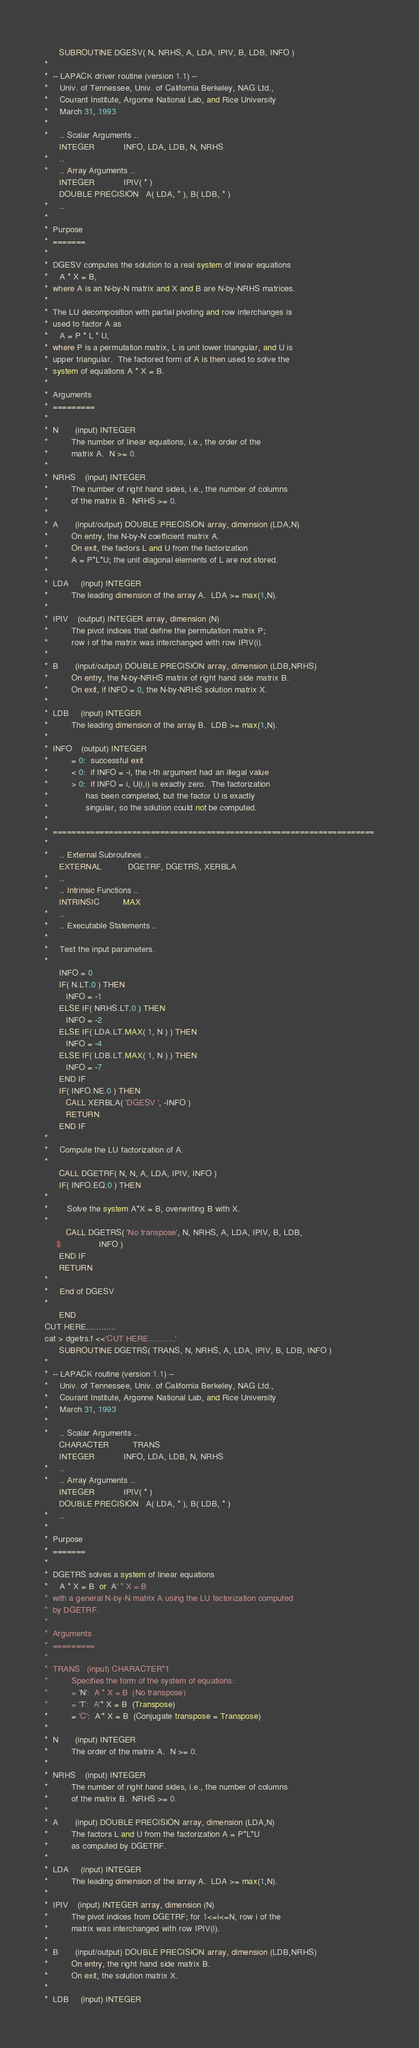<code> <loc_0><loc_0><loc_500><loc_500><_FORTRAN_>
      SUBROUTINE DGESV( N, NRHS, A, LDA, IPIV, B, LDB, INFO )
*
*  -- LAPACK driver routine (version 1.1) --
*     Univ. of Tennessee, Univ. of California Berkeley, NAG Ltd.,
*     Courant Institute, Argonne National Lab, and Rice University
*     March 31, 1993
*
*     .. Scalar Arguments ..
      INTEGER            INFO, LDA, LDB, N, NRHS
*     ..
*     .. Array Arguments ..
      INTEGER            IPIV( * )
      DOUBLE PRECISION   A( LDA, * ), B( LDB, * )
*     ..
*
*  Purpose
*  =======
*
*  DGESV computes the solution to a real system of linear equations
*     A * X = B,
*  where A is an N-by-N matrix and X and B are N-by-NRHS matrices.
*
*  The LU decomposition with partial pivoting and row interchanges is
*  used to factor A as
*     A = P * L * U,
*  where P is a permutation matrix, L is unit lower triangular, and U is
*  upper triangular.  The factored form of A is then used to solve the
*  system of equations A * X = B.
*
*  Arguments
*  =========
*
*  N       (input) INTEGER
*          The number of linear equations, i.e., the order of the
*          matrix A.  N >= 0.
*
*  NRHS    (input) INTEGER
*          The number of right hand sides, i.e., the number of columns
*          of the matrix B.  NRHS >= 0.
*
*  A       (input/output) DOUBLE PRECISION array, dimension (LDA,N)
*          On entry, the N-by-N coefficient matrix A.
*          On exit, the factors L and U from the factorization
*          A = P*L*U; the unit diagonal elements of L are not stored.
*
*  LDA     (input) INTEGER
*          The leading dimension of the array A.  LDA >= max(1,N).
*
*  IPIV    (output) INTEGER array, dimension (N)
*          The pivot indices that define the permutation matrix P;
*          row i of the matrix was interchanged with row IPIV(i).
*
*  B       (input/output) DOUBLE PRECISION array, dimension (LDB,NRHS)
*          On entry, the N-by-NRHS matrix of right hand side matrix B.
*          On exit, if INFO = 0, the N-by-NRHS solution matrix X.
*
*  LDB     (input) INTEGER
*          The leading dimension of the array B.  LDB >= max(1,N).
*
*  INFO    (output) INTEGER
*          = 0:  successful exit
*          < 0:  if INFO = -i, the i-th argument had an illegal value
*          > 0:  if INFO = i, U(i,i) is exactly zero.  The factorization
*                has been completed, but the factor U is exactly
*                singular, so the solution could not be computed.
*
*  =====================================================================
*
*     .. External Subroutines ..
      EXTERNAL           DGETRF, DGETRS, XERBLA
*     ..
*     .. Intrinsic Functions ..
      INTRINSIC          MAX
*     ..
*     .. Executable Statements ..
*
*     Test the input parameters.
*
      INFO = 0
      IF( N.LT.0 ) THEN
         INFO = -1
      ELSE IF( NRHS.LT.0 ) THEN
         INFO = -2
      ELSE IF( LDA.LT.MAX( 1, N ) ) THEN
         INFO = -4
      ELSE IF( LDB.LT.MAX( 1, N ) ) THEN
         INFO = -7
      END IF
      IF( INFO.NE.0 ) THEN
         CALL XERBLA( 'DGESV ', -INFO )
         RETURN
      END IF
*
*     Compute the LU factorization of A.
*
      CALL DGETRF( N, N, A, LDA, IPIV, INFO )
      IF( INFO.EQ.0 ) THEN
*
*        Solve the system A*X = B, overwriting B with X.
*
         CALL DGETRS( 'No transpose', N, NRHS, A, LDA, IPIV, B, LDB,
     $                INFO )
      END IF
      RETURN
*
*     End of DGESV
*
      END
CUT HERE............
cat > dgetrs.f <<'CUT HERE............'
      SUBROUTINE DGETRS( TRANS, N, NRHS, A, LDA, IPIV, B, LDB, INFO )
*
*  -- LAPACK routine (version 1.1) --
*     Univ. of Tennessee, Univ. of California Berkeley, NAG Ltd.,
*     Courant Institute, Argonne National Lab, and Rice University
*     March 31, 1993
*
*     .. Scalar Arguments ..
      CHARACTER          TRANS
      INTEGER            INFO, LDA, LDB, N, NRHS
*     ..
*     .. Array Arguments ..
      INTEGER            IPIV( * )
      DOUBLE PRECISION   A( LDA, * ), B( LDB, * )
*     ..
*
*  Purpose
*  =======
*
*  DGETRS solves a system of linear equations
*     A * X = B  or  A' * X = B
*  with a general N-by-N matrix A using the LU factorization computed
*  by DGETRF.
*
*  Arguments
*  =========
*
*  TRANS   (input) CHARACTER*1
*          Specifies the form of the system of equations:
*          = 'N':  A * X = B  (No transpose)
*          = 'T':  A'* X = B  (Transpose)
*          = 'C':  A'* X = B  (Conjugate transpose = Transpose)
*
*  N       (input) INTEGER
*          The order of the matrix A.  N >= 0.
*
*  NRHS    (input) INTEGER
*          The number of right hand sides, i.e., the number of columns
*          of the matrix B.  NRHS >= 0.
*
*  A       (input) DOUBLE PRECISION array, dimension (LDA,N)
*          The factors L and U from the factorization A = P*L*U
*          as computed by DGETRF.
*
*  LDA     (input) INTEGER
*          The leading dimension of the array A.  LDA >= max(1,N).
*
*  IPIV    (input) INTEGER array, dimension (N)
*          The pivot indices from DGETRF; for 1<=i<=N, row i of the
*          matrix was interchanged with row IPIV(i).
*
*  B       (input/output) DOUBLE PRECISION array, dimension (LDB,NRHS)
*          On entry, the right hand side matrix B.
*          On exit, the solution matrix X.
*
*  LDB     (input) INTEGER</code> 